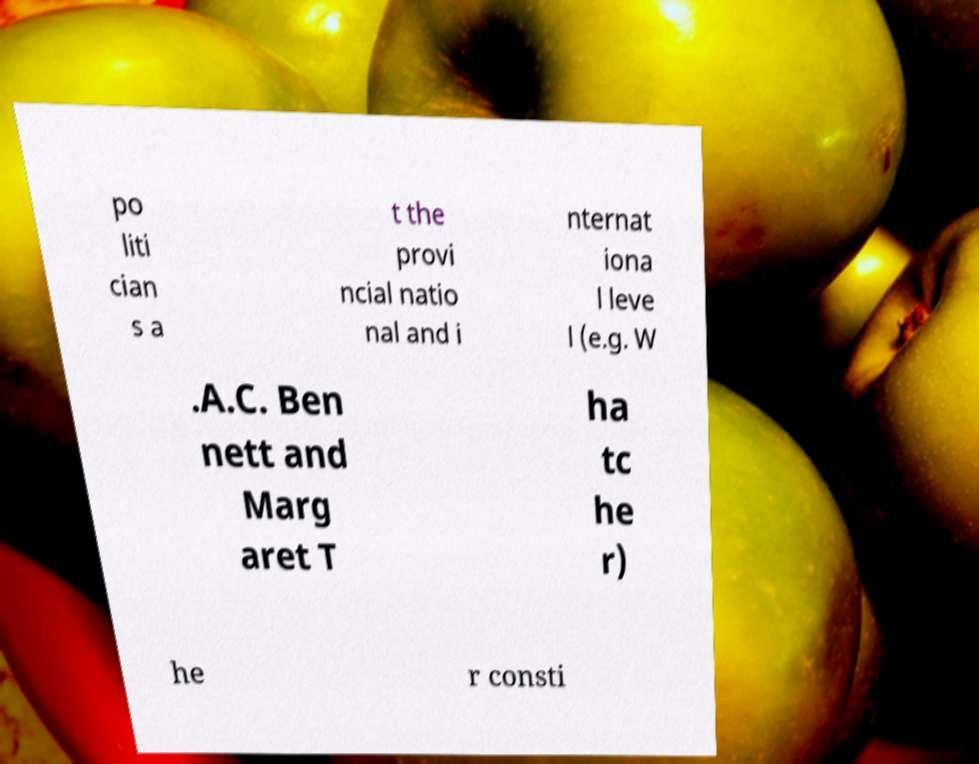What messages or text are displayed in this image? I need them in a readable, typed format. po liti cian s a t the provi ncial natio nal and i nternat iona l leve l (e.g. W .A.C. Ben nett and Marg aret T ha tc he r) he r consti 